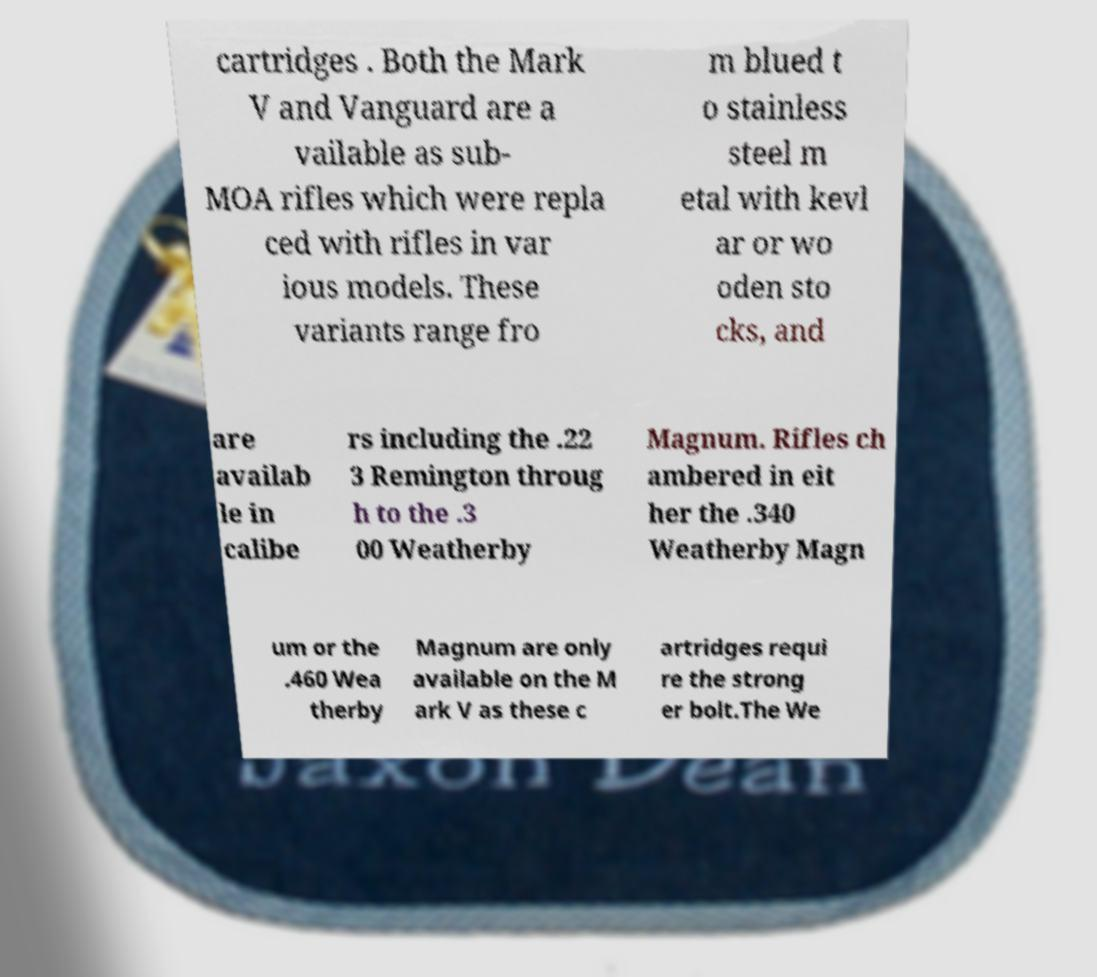Could you extract and type out the text from this image? cartridges . Both the Mark V and Vanguard are a vailable as sub- MOA rifles which were repla ced with rifles in var ious models. These variants range fro m blued t o stainless steel m etal with kevl ar or wo oden sto cks, and are availab le in calibe rs including the .22 3 Remington throug h to the .3 00 Weatherby Magnum. Rifles ch ambered in eit her the .340 Weatherby Magn um or the .460 Wea therby Magnum are only available on the M ark V as these c artridges requi re the strong er bolt.The We 